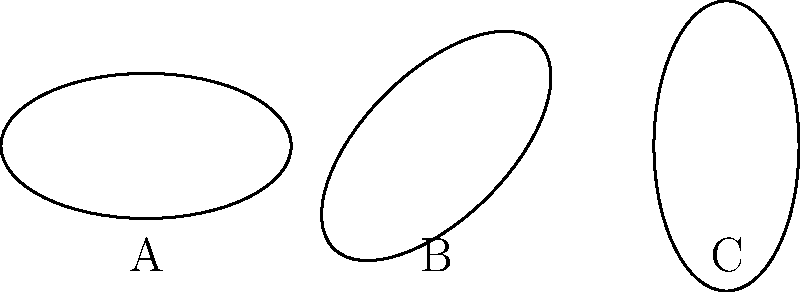In a galaxy cluster simulation, three dark matter halo shapes are represented by ellipses A, B, and C. Which of these ellipses are congruent, considering their orientation? To determine congruence among the ellipses, we need to follow these steps:

1. Examine the size and shape of each ellipse:
   All three ellipses appear to have the same size and shape (major axis = 2, minor axis = 1).

2. Consider the orientation:
   A: Horizontal orientation (0° rotation)
   B: Rotated 45° clockwise
   C: Rotated 90° clockwise (vertical orientation)

3. Congruence definition:
   Two shapes are congruent if they have the same size and shape, regardless of their orientation.

4. Apply the congruence definition:
   Since all three ellipses have the same size and shape, they are all congruent to each other, despite their different orientations.

5. Conclusion:
   Ellipses A, B, and C are all congruent to each other.

This concept is crucial in astrophysics when analyzing dark matter halo shapes in galaxy cluster simulations, as it allows for the comparison of halo structures regardless of their spatial orientation in the simulated cluster.
Answer: A, B, and C 